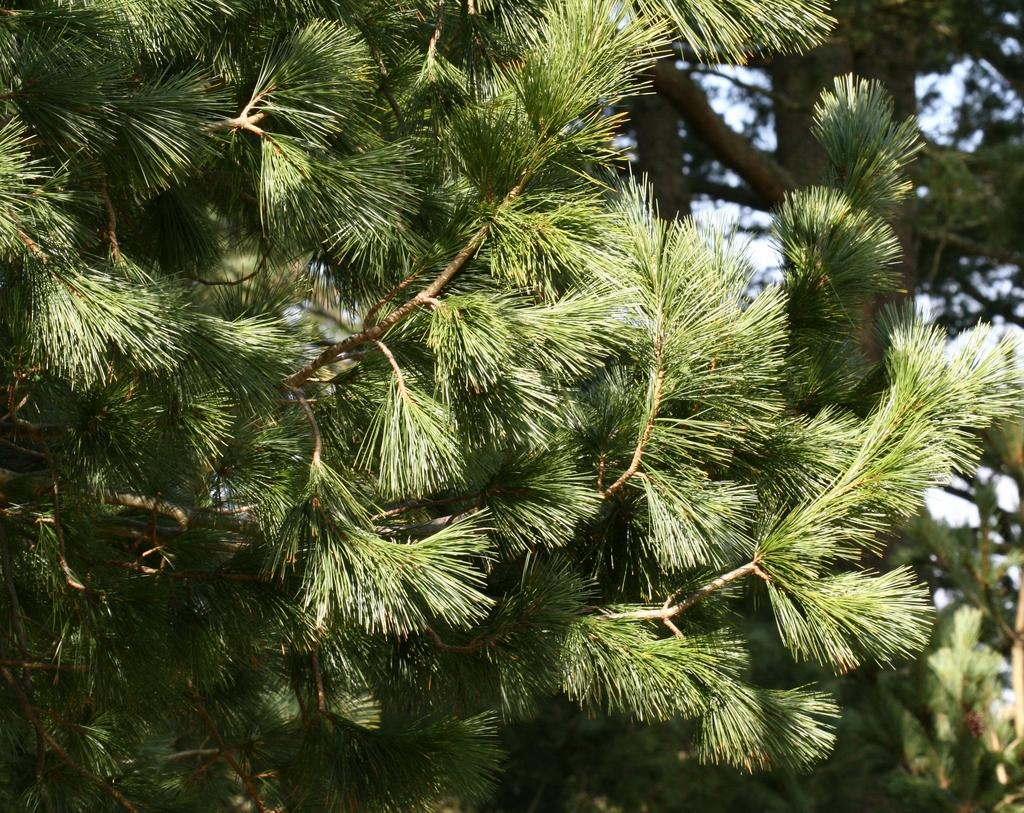What type of plant can be seen in the image? There is a tree with leaves in the image. Are there any other trees visible in the image? Yes, there is another tree visible in the background of the image. What part of the natural environment is visible in the image? The sky is partially visible from behind the trees in the background. What type of income can be seen in the image? There is no reference to income in the image; it features trees and a partially visible sky. 